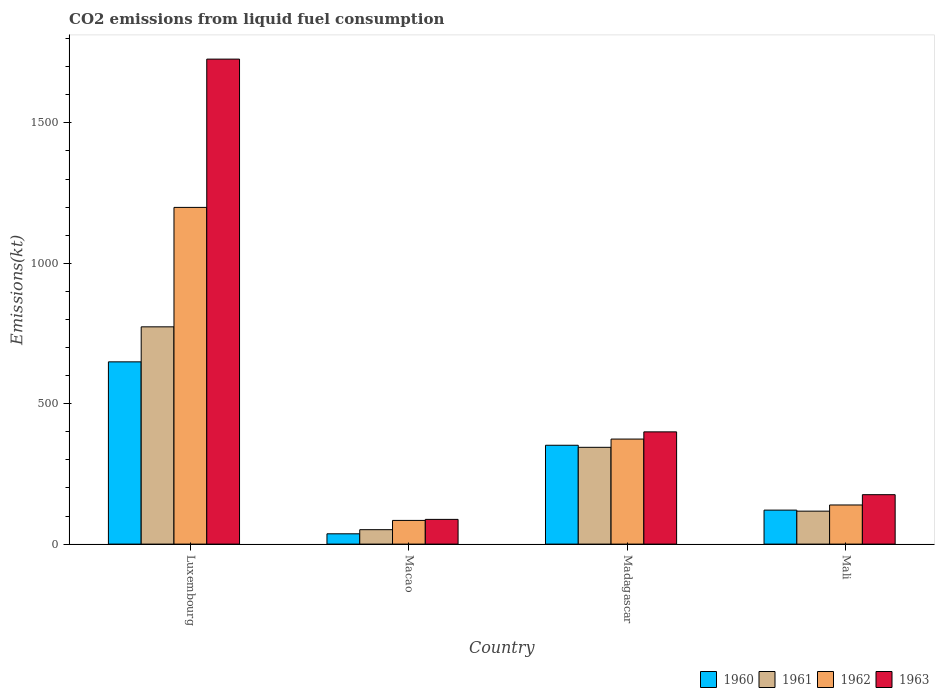Are the number of bars per tick equal to the number of legend labels?
Keep it short and to the point. Yes. Are the number of bars on each tick of the X-axis equal?
Keep it short and to the point. Yes. What is the label of the 2nd group of bars from the left?
Offer a very short reply. Macao. What is the amount of CO2 emitted in 1963 in Macao?
Your answer should be compact. 88.01. Across all countries, what is the maximum amount of CO2 emitted in 1963?
Provide a short and direct response. 1727.16. Across all countries, what is the minimum amount of CO2 emitted in 1960?
Provide a short and direct response. 36.67. In which country was the amount of CO2 emitted in 1960 maximum?
Give a very brief answer. Luxembourg. In which country was the amount of CO2 emitted in 1962 minimum?
Provide a succinct answer. Macao. What is the total amount of CO2 emitted in 1960 in the graph?
Make the answer very short. 1158.77. What is the difference between the amount of CO2 emitted in 1961 in Macao and that in Mali?
Provide a succinct answer. -66.01. What is the difference between the amount of CO2 emitted in 1963 in Madagascar and the amount of CO2 emitted in 1962 in Mali?
Provide a short and direct response. 260.36. What is the average amount of CO2 emitted in 1963 per country?
Give a very brief answer. 597.72. What is the difference between the amount of CO2 emitted of/in 1963 and amount of CO2 emitted of/in 1961 in Mali?
Ensure brevity in your answer.  58.67. In how many countries, is the amount of CO2 emitted in 1960 greater than 1600 kt?
Your response must be concise. 0. What is the ratio of the amount of CO2 emitted in 1961 in Luxembourg to that in Macao?
Keep it short and to the point. 15.07. Is the difference between the amount of CO2 emitted in 1963 in Macao and Mali greater than the difference between the amount of CO2 emitted in 1961 in Macao and Mali?
Ensure brevity in your answer.  No. What is the difference between the highest and the second highest amount of CO2 emitted in 1962?
Offer a terse response. -234.69. What is the difference between the highest and the lowest amount of CO2 emitted in 1963?
Provide a short and direct response. 1639.15. In how many countries, is the amount of CO2 emitted in 1963 greater than the average amount of CO2 emitted in 1963 taken over all countries?
Give a very brief answer. 1. Is the sum of the amount of CO2 emitted in 1962 in Luxembourg and Mali greater than the maximum amount of CO2 emitted in 1961 across all countries?
Your answer should be very brief. Yes. Is it the case that in every country, the sum of the amount of CO2 emitted in 1960 and amount of CO2 emitted in 1962 is greater than the sum of amount of CO2 emitted in 1961 and amount of CO2 emitted in 1963?
Your response must be concise. No. What does the 4th bar from the right in Luxembourg represents?
Your response must be concise. 1960. Is it the case that in every country, the sum of the amount of CO2 emitted in 1961 and amount of CO2 emitted in 1962 is greater than the amount of CO2 emitted in 1960?
Ensure brevity in your answer.  Yes. How many countries are there in the graph?
Provide a short and direct response. 4. Are the values on the major ticks of Y-axis written in scientific E-notation?
Give a very brief answer. No. Does the graph contain any zero values?
Provide a short and direct response. No. Does the graph contain grids?
Give a very brief answer. No. Where does the legend appear in the graph?
Your response must be concise. Bottom right. How are the legend labels stacked?
Give a very brief answer. Horizontal. What is the title of the graph?
Ensure brevity in your answer.  CO2 emissions from liquid fuel consumption. Does "1999" appear as one of the legend labels in the graph?
Your answer should be very brief. No. What is the label or title of the X-axis?
Offer a terse response. Country. What is the label or title of the Y-axis?
Your answer should be compact. Emissions(kt). What is the Emissions(kt) in 1960 in Luxembourg?
Ensure brevity in your answer.  649.06. What is the Emissions(kt) of 1961 in Luxembourg?
Offer a terse response. 773.74. What is the Emissions(kt) of 1962 in Luxembourg?
Give a very brief answer. 1199.11. What is the Emissions(kt) in 1963 in Luxembourg?
Offer a terse response. 1727.16. What is the Emissions(kt) in 1960 in Macao?
Offer a very short reply. 36.67. What is the Emissions(kt) of 1961 in Macao?
Your answer should be compact. 51.34. What is the Emissions(kt) of 1962 in Macao?
Ensure brevity in your answer.  84.34. What is the Emissions(kt) of 1963 in Macao?
Provide a succinct answer. 88.01. What is the Emissions(kt) of 1960 in Madagascar?
Offer a terse response. 352.03. What is the Emissions(kt) in 1961 in Madagascar?
Offer a very short reply. 344.7. What is the Emissions(kt) in 1962 in Madagascar?
Provide a succinct answer. 374.03. What is the Emissions(kt) of 1963 in Madagascar?
Your answer should be very brief. 399.7. What is the Emissions(kt) in 1960 in Mali?
Your response must be concise. 121.01. What is the Emissions(kt) of 1961 in Mali?
Provide a short and direct response. 117.34. What is the Emissions(kt) in 1962 in Mali?
Your answer should be very brief. 139.35. What is the Emissions(kt) of 1963 in Mali?
Give a very brief answer. 176.02. Across all countries, what is the maximum Emissions(kt) in 1960?
Give a very brief answer. 649.06. Across all countries, what is the maximum Emissions(kt) of 1961?
Provide a short and direct response. 773.74. Across all countries, what is the maximum Emissions(kt) of 1962?
Offer a very short reply. 1199.11. Across all countries, what is the maximum Emissions(kt) of 1963?
Provide a short and direct response. 1727.16. Across all countries, what is the minimum Emissions(kt) in 1960?
Offer a very short reply. 36.67. Across all countries, what is the minimum Emissions(kt) in 1961?
Your answer should be compact. 51.34. Across all countries, what is the minimum Emissions(kt) in 1962?
Make the answer very short. 84.34. Across all countries, what is the minimum Emissions(kt) of 1963?
Offer a terse response. 88.01. What is the total Emissions(kt) of 1960 in the graph?
Ensure brevity in your answer.  1158.77. What is the total Emissions(kt) in 1961 in the graph?
Offer a terse response. 1287.12. What is the total Emissions(kt) in 1962 in the graph?
Make the answer very short. 1796.83. What is the total Emissions(kt) in 1963 in the graph?
Ensure brevity in your answer.  2390.88. What is the difference between the Emissions(kt) in 1960 in Luxembourg and that in Macao?
Your answer should be very brief. 612.39. What is the difference between the Emissions(kt) in 1961 in Luxembourg and that in Macao?
Give a very brief answer. 722.4. What is the difference between the Emissions(kt) of 1962 in Luxembourg and that in Macao?
Your response must be concise. 1114.77. What is the difference between the Emissions(kt) of 1963 in Luxembourg and that in Macao?
Your response must be concise. 1639.15. What is the difference between the Emissions(kt) in 1960 in Luxembourg and that in Madagascar?
Provide a succinct answer. 297.03. What is the difference between the Emissions(kt) in 1961 in Luxembourg and that in Madagascar?
Your answer should be compact. 429.04. What is the difference between the Emissions(kt) of 1962 in Luxembourg and that in Madagascar?
Your answer should be compact. 825.08. What is the difference between the Emissions(kt) of 1963 in Luxembourg and that in Madagascar?
Offer a very short reply. 1327.45. What is the difference between the Emissions(kt) in 1960 in Luxembourg and that in Mali?
Offer a very short reply. 528.05. What is the difference between the Emissions(kt) of 1961 in Luxembourg and that in Mali?
Your response must be concise. 656.39. What is the difference between the Emissions(kt) in 1962 in Luxembourg and that in Mali?
Provide a short and direct response. 1059.76. What is the difference between the Emissions(kt) in 1963 in Luxembourg and that in Mali?
Your answer should be very brief. 1551.14. What is the difference between the Emissions(kt) of 1960 in Macao and that in Madagascar?
Make the answer very short. -315.36. What is the difference between the Emissions(kt) of 1961 in Macao and that in Madagascar?
Provide a succinct answer. -293.36. What is the difference between the Emissions(kt) of 1962 in Macao and that in Madagascar?
Ensure brevity in your answer.  -289.69. What is the difference between the Emissions(kt) in 1963 in Macao and that in Madagascar?
Make the answer very short. -311.69. What is the difference between the Emissions(kt) in 1960 in Macao and that in Mali?
Provide a succinct answer. -84.34. What is the difference between the Emissions(kt) of 1961 in Macao and that in Mali?
Provide a short and direct response. -66.01. What is the difference between the Emissions(kt) of 1962 in Macao and that in Mali?
Offer a very short reply. -55.01. What is the difference between the Emissions(kt) of 1963 in Macao and that in Mali?
Keep it short and to the point. -88.01. What is the difference between the Emissions(kt) of 1960 in Madagascar and that in Mali?
Provide a short and direct response. 231.02. What is the difference between the Emissions(kt) in 1961 in Madagascar and that in Mali?
Provide a succinct answer. 227.35. What is the difference between the Emissions(kt) of 1962 in Madagascar and that in Mali?
Your answer should be very brief. 234.69. What is the difference between the Emissions(kt) of 1963 in Madagascar and that in Mali?
Keep it short and to the point. 223.69. What is the difference between the Emissions(kt) in 1960 in Luxembourg and the Emissions(kt) in 1961 in Macao?
Your answer should be compact. 597.72. What is the difference between the Emissions(kt) of 1960 in Luxembourg and the Emissions(kt) of 1962 in Macao?
Your answer should be compact. 564.72. What is the difference between the Emissions(kt) of 1960 in Luxembourg and the Emissions(kt) of 1963 in Macao?
Your answer should be very brief. 561.05. What is the difference between the Emissions(kt) of 1961 in Luxembourg and the Emissions(kt) of 1962 in Macao?
Keep it short and to the point. 689.4. What is the difference between the Emissions(kt) of 1961 in Luxembourg and the Emissions(kt) of 1963 in Macao?
Your response must be concise. 685.73. What is the difference between the Emissions(kt) of 1962 in Luxembourg and the Emissions(kt) of 1963 in Macao?
Provide a succinct answer. 1111.1. What is the difference between the Emissions(kt) of 1960 in Luxembourg and the Emissions(kt) of 1961 in Madagascar?
Give a very brief answer. 304.36. What is the difference between the Emissions(kt) in 1960 in Luxembourg and the Emissions(kt) in 1962 in Madagascar?
Make the answer very short. 275.02. What is the difference between the Emissions(kt) in 1960 in Luxembourg and the Emissions(kt) in 1963 in Madagascar?
Ensure brevity in your answer.  249.36. What is the difference between the Emissions(kt) in 1961 in Luxembourg and the Emissions(kt) in 1962 in Madagascar?
Your answer should be very brief. 399.7. What is the difference between the Emissions(kt) of 1961 in Luxembourg and the Emissions(kt) of 1963 in Madagascar?
Provide a succinct answer. 374.03. What is the difference between the Emissions(kt) in 1962 in Luxembourg and the Emissions(kt) in 1963 in Madagascar?
Your answer should be very brief. 799.41. What is the difference between the Emissions(kt) of 1960 in Luxembourg and the Emissions(kt) of 1961 in Mali?
Provide a succinct answer. 531.72. What is the difference between the Emissions(kt) of 1960 in Luxembourg and the Emissions(kt) of 1962 in Mali?
Keep it short and to the point. 509.71. What is the difference between the Emissions(kt) of 1960 in Luxembourg and the Emissions(kt) of 1963 in Mali?
Give a very brief answer. 473.04. What is the difference between the Emissions(kt) of 1961 in Luxembourg and the Emissions(kt) of 1962 in Mali?
Give a very brief answer. 634.39. What is the difference between the Emissions(kt) in 1961 in Luxembourg and the Emissions(kt) in 1963 in Mali?
Give a very brief answer. 597.72. What is the difference between the Emissions(kt) in 1962 in Luxembourg and the Emissions(kt) in 1963 in Mali?
Make the answer very short. 1023.09. What is the difference between the Emissions(kt) of 1960 in Macao and the Emissions(kt) of 1961 in Madagascar?
Provide a short and direct response. -308.03. What is the difference between the Emissions(kt) in 1960 in Macao and the Emissions(kt) in 1962 in Madagascar?
Keep it short and to the point. -337.36. What is the difference between the Emissions(kt) of 1960 in Macao and the Emissions(kt) of 1963 in Madagascar?
Make the answer very short. -363.03. What is the difference between the Emissions(kt) in 1961 in Macao and the Emissions(kt) in 1962 in Madagascar?
Offer a terse response. -322.7. What is the difference between the Emissions(kt) in 1961 in Macao and the Emissions(kt) in 1963 in Madagascar?
Your response must be concise. -348.37. What is the difference between the Emissions(kt) of 1962 in Macao and the Emissions(kt) of 1963 in Madagascar?
Keep it short and to the point. -315.36. What is the difference between the Emissions(kt) of 1960 in Macao and the Emissions(kt) of 1961 in Mali?
Offer a very short reply. -80.67. What is the difference between the Emissions(kt) in 1960 in Macao and the Emissions(kt) in 1962 in Mali?
Provide a succinct answer. -102.68. What is the difference between the Emissions(kt) of 1960 in Macao and the Emissions(kt) of 1963 in Mali?
Offer a very short reply. -139.35. What is the difference between the Emissions(kt) in 1961 in Macao and the Emissions(kt) in 1962 in Mali?
Your answer should be compact. -88.01. What is the difference between the Emissions(kt) in 1961 in Macao and the Emissions(kt) in 1963 in Mali?
Provide a short and direct response. -124.68. What is the difference between the Emissions(kt) of 1962 in Macao and the Emissions(kt) of 1963 in Mali?
Offer a very short reply. -91.67. What is the difference between the Emissions(kt) of 1960 in Madagascar and the Emissions(kt) of 1961 in Mali?
Your answer should be compact. 234.69. What is the difference between the Emissions(kt) in 1960 in Madagascar and the Emissions(kt) in 1962 in Mali?
Your response must be concise. 212.69. What is the difference between the Emissions(kt) in 1960 in Madagascar and the Emissions(kt) in 1963 in Mali?
Offer a terse response. 176.02. What is the difference between the Emissions(kt) of 1961 in Madagascar and the Emissions(kt) of 1962 in Mali?
Provide a short and direct response. 205.35. What is the difference between the Emissions(kt) in 1961 in Madagascar and the Emissions(kt) in 1963 in Mali?
Your response must be concise. 168.68. What is the difference between the Emissions(kt) of 1962 in Madagascar and the Emissions(kt) of 1963 in Mali?
Provide a succinct answer. 198.02. What is the average Emissions(kt) in 1960 per country?
Keep it short and to the point. 289.69. What is the average Emissions(kt) in 1961 per country?
Offer a terse response. 321.78. What is the average Emissions(kt) of 1962 per country?
Your answer should be compact. 449.21. What is the average Emissions(kt) in 1963 per country?
Offer a very short reply. 597.72. What is the difference between the Emissions(kt) in 1960 and Emissions(kt) in 1961 in Luxembourg?
Make the answer very short. -124.68. What is the difference between the Emissions(kt) of 1960 and Emissions(kt) of 1962 in Luxembourg?
Provide a succinct answer. -550.05. What is the difference between the Emissions(kt) in 1960 and Emissions(kt) in 1963 in Luxembourg?
Your answer should be very brief. -1078.1. What is the difference between the Emissions(kt) of 1961 and Emissions(kt) of 1962 in Luxembourg?
Ensure brevity in your answer.  -425.37. What is the difference between the Emissions(kt) of 1961 and Emissions(kt) of 1963 in Luxembourg?
Your answer should be very brief. -953.42. What is the difference between the Emissions(kt) in 1962 and Emissions(kt) in 1963 in Luxembourg?
Provide a short and direct response. -528.05. What is the difference between the Emissions(kt) in 1960 and Emissions(kt) in 1961 in Macao?
Provide a short and direct response. -14.67. What is the difference between the Emissions(kt) of 1960 and Emissions(kt) of 1962 in Macao?
Give a very brief answer. -47.67. What is the difference between the Emissions(kt) of 1960 and Emissions(kt) of 1963 in Macao?
Offer a terse response. -51.34. What is the difference between the Emissions(kt) in 1961 and Emissions(kt) in 1962 in Macao?
Your response must be concise. -33. What is the difference between the Emissions(kt) in 1961 and Emissions(kt) in 1963 in Macao?
Make the answer very short. -36.67. What is the difference between the Emissions(kt) of 1962 and Emissions(kt) of 1963 in Macao?
Provide a succinct answer. -3.67. What is the difference between the Emissions(kt) in 1960 and Emissions(kt) in 1961 in Madagascar?
Your answer should be very brief. 7.33. What is the difference between the Emissions(kt) of 1960 and Emissions(kt) of 1962 in Madagascar?
Keep it short and to the point. -22. What is the difference between the Emissions(kt) of 1960 and Emissions(kt) of 1963 in Madagascar?
Give a very brief answer. -47.67. What is the difference between the Emissions(kt) in 1961 and Emissions(kt) in 1962 in Madagascar?
Give a very brief answer. -29.34. What is the difference between the Emissions(kt) in 1961 and Emissions(kt) in 1963 in Madagascar?
Ensure brevity in your answer.  -55.01. What is the difference between the Emissions(kt) of 1962 and Emissions(kt) of 1963 in Madagascar?
Your response must be concise. -25.67. What is the difference between the Emissions(kt) of 1960 and Emissions(kt) of 1961 in Mali?
Give a very brief answer. 3.67. What is the difference between the Emissions(kt) of 1960 and Emissions(kt) of 1962 in Mali?
Keep it short and to the point. -18.34. What is the difference between the Emissions(kt) of 1960 and Emissions(kt) of 1963 in Mali?
Provide a succinct answer. -55.01. What is the difference between the Emissions(kt) of 1961 and Emissions(kt) of 1962 in Mali?
Provide a short and direct response. -22. What is the difference between the Emissions(kt) of 1961 and Emissions(kt) of 1963 in Mali?
Offer a terse response. -58.67. What is the difference between the Emissions(kt) of 1962 and Emissions(kt) of 1963 in Mali?
Keep it short and to the point. -36.67. What is the ratio of the Emissions(kt) of 1960 in Luxembourg to that in Macao?
Provide a succinct answer. 17.7. What is the ratio of the Emissions(kt) in 1961 in Luxembourg to that in Macao?
Your response must be concise. 15.07. What is the ratio of the Emissions(kt) in 1962 in Luxembourg to that in Macao?
Provide a succinct answer. 14.22. What is the ratio of the Emissions(kt) of 1963 in Luxembourg to that in Macao?
Provide a succinct answer. 19.62. What is the ratio of the Emissions(kt) in 1960 in Luxembourg to that in Madagascar?
Give a very brief answer. 1.84. What is the ratio of the Emissions(kt) in 1961 in Luxembourg to that in Madagascar?
Keep it short and to the point. 2.24. What is the ratio of the Emissions(kt) of 1962 in Luxembourg to that in Madagascar?
Ensure brevity in your answer.  3.21. What is the ratio of the Emissions(kt) of 1963 in Luxembourg to that in Madagascar?
Keep it short and to the point. 4.32. What is the ratio of the Emissions(kt) in 1960 in Luxembourg to that in Mali?
Provide a succinct answer. 5.36. What is the ratio of the Emissions(kt) of 1961 in Luxembourg to that in Mali?
Make the answer very short. 6.59. What is the ratio of the Emissions(kt) in 1962 in Luxembourg to that in Mali?
Your answer should be very brief. 8.61. What is the ratio of the Emissions(kt) in 1963 in Luxembourg to that in Mali?
Your answer should be very brief. 9.81. What is the ratio of the Emissions(kt) of 1960 in Macao to that in Madagascar?
Offer a terse response. 0.1. What is the ratio of the Emissions(kt) of 1961 in Macao to that in Madagascar?
Your answer should be compact. 0.15. What is the ratio of the Emissions(kt) of 1962 in Macao to that in Madagascar?
Provide a short and direct response. 0.23. What is the ratio of the Emissions(kt) in 1963 in Macao to that in Madagascar?
Offer a terse response. 0.22. What is the ratio of the Emissions(kt) of 1960 in Macao to that in Mali?
Your answer should be very brief. 0.3. What is the ratio of the Emissions(kt) of 1961 in Macao to that in Mali?
Keep it short and to the point. 0.44. What is the ratio of the Emissions(kt) in 1962 in Macao to that in Mali?
Give a very brief answer. 0.61. What is the ratio of the Emissions(kt) of 1963 in Macao to that in Mali?
Your answer should be very brief. 0.5. What is the ratio of the Emissions(kt) in 1960 in Madagascar to that in Mali?
Give a very brief answer. 2.91. What is the ratio of the Emissions(kt) of 1961 in Madagascar to that in Mali?
Keep it short and to the point. 2.94. What is the ratio of the Emissions(kt) in 1962 in Madagascar to that in Mali?
Ensure brevity in your answer.  2.68. What is the ratio of the Emissions(kt) of 1963 in Madagascar to that in Mali?
Your answer should be very brief. 2.27. What is the difference between the highest and the second highest Emissions(kt) of 1960?
Your response must be concise. 297.03. What is the difference between the highest and the second highest Emissions(kt) in 1961?
Provide a short and direct response. 429.04. What is the difference between the highest and the second highest Emissions(kt) of 1962?
Offer a terse response. 825.08. What is the difference between the highest and the second highest Emissions(kt) of 1963?
Your response must be concise. 1327.45. What is the difference between the highest and the lowest Emissions(kt) of 1960?
Your answer should be very brief. 612.39. What is the difference between the highest and the lowest Emissions(kt) of 1961?
Provide a succinct answer. 722.4. What is the difference between the highest and the lowest Emissions(kt) of 1962?
Offer a very short reply. 1114.77. What is the difference between the highest and the lowest Emissions(kt) in 1963?
Your answer should be very brief. 1639.15. 